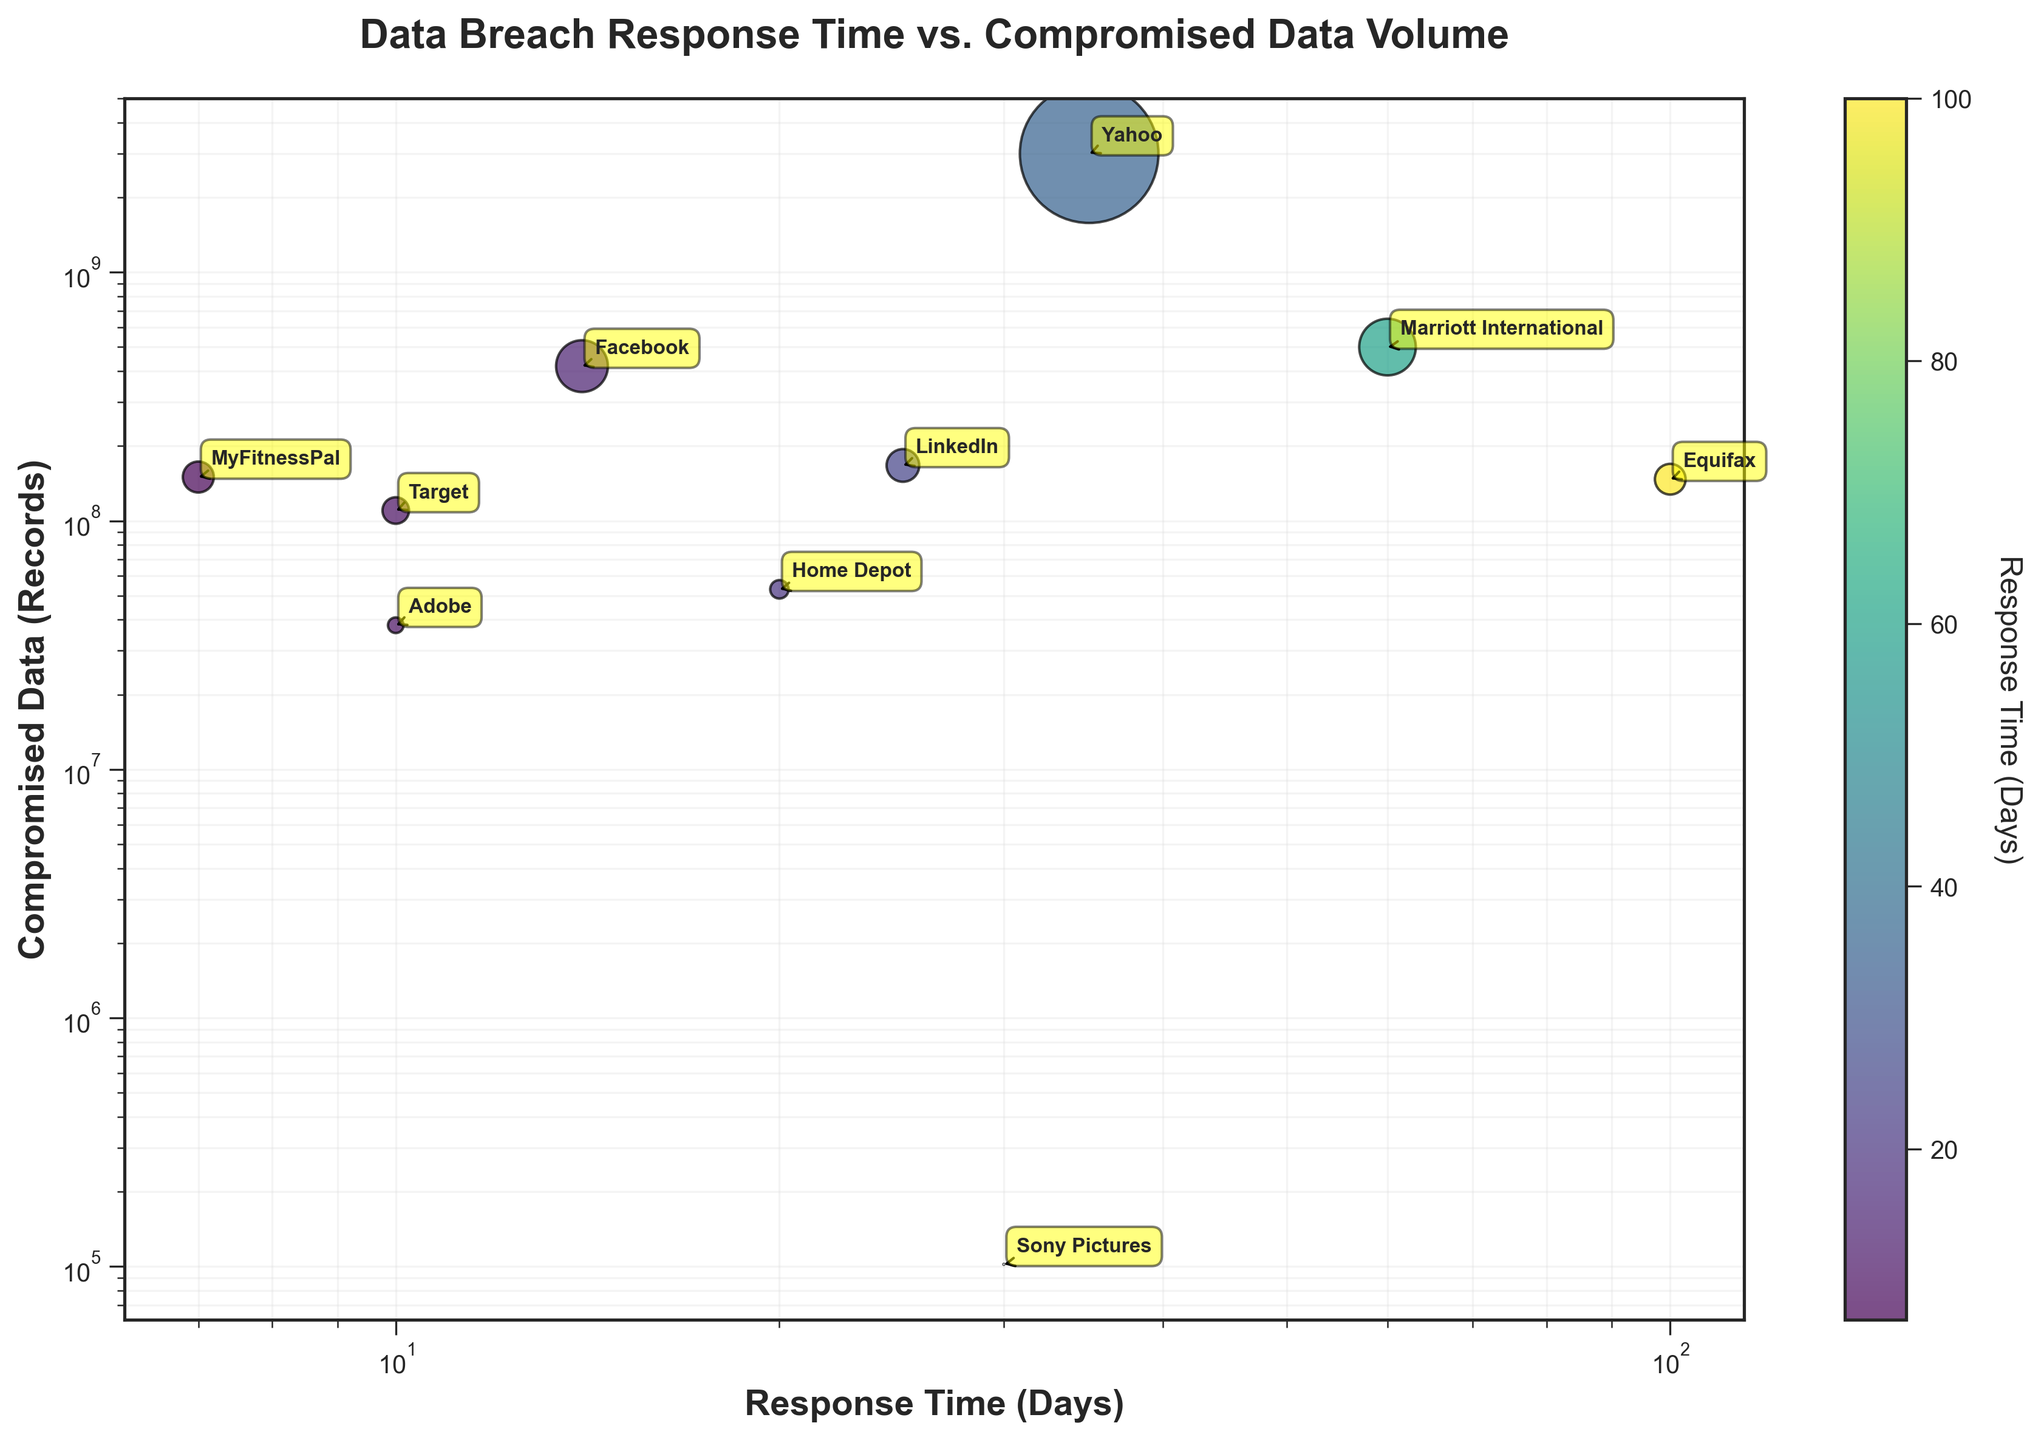What is the title of the plot? The title is usually displayed at the top of the plot. Here, it reads "Data Breach Response Time vs. Compromised Data Volume".
Answer: Data Breach Response Time vs. Compromised Data Volume What is the color indicating in the scatter plot? The color of the points in the scatter plot is based on the response time in days, as indicated by the color bar on the side of the plot.
Answer: Response Time (Days) Which company had the largest volume of compromised data? By visually inspecting the y-axis values and the size of the points, the largest volume of compromised data corresponds to Yahoo with 3,000,000,000 records.
Answer: Yahoo Which company responded the fastest to a data breach? Looking at the x-axis on a logarithmic scale, the smallest value represents the fastest response. MyFitnessPal responded in 7 days, the fastest among all companies.
Answer: MyFitnessPal Compare the response time and the volume of compromised data between Equifax and Facebook. Equifax has a response time of 100 days and compromised data of 147,000,000 records. Facebook has a response time of 14 days and compromised data of 419,000,000 records. Despite Facebook responding faster, they had a larger volume of compromised data.
Answer: Equifax responded slower and had fewer records compromised compared to Facebook Which company has a response time closest to the average response time of all companies? The average response time can be calculated by summing the response times and dividing by the number of companies. Average = (100 + 35 + 10 + 20 + 30 + 60 + 10 + 25 + 14 + 7) / 10 = 31.1 days. LinkedIn, with a response time of 25 days, is closest to the average.
Answer: LinkedIn What is the relationship between the size of the data points and the volume of compromised data? The size of the data points is proportional to the volume of compromised data. Larger data points indicate a larger volume of compromised data.
Answer: Proportional Is there a general trend between response time and volume of compromised data? By examining the scatter plot, there's no clear trend showing a direct correlation between response time and the volume of compromised data. The data points are scattered without a clear pattern linking the two variables.
Answer: No clear trend Which company has a smaller response time than Sony Pictures but a larger volume of compromised data? Checking the companies with a response time smaller than 30 days and comparing their compromised data, LinkedIn (25 days, 167,000,000 records) has a smaller response time than Sony Pictures but more compromised data.
Answer: LinkedIn 